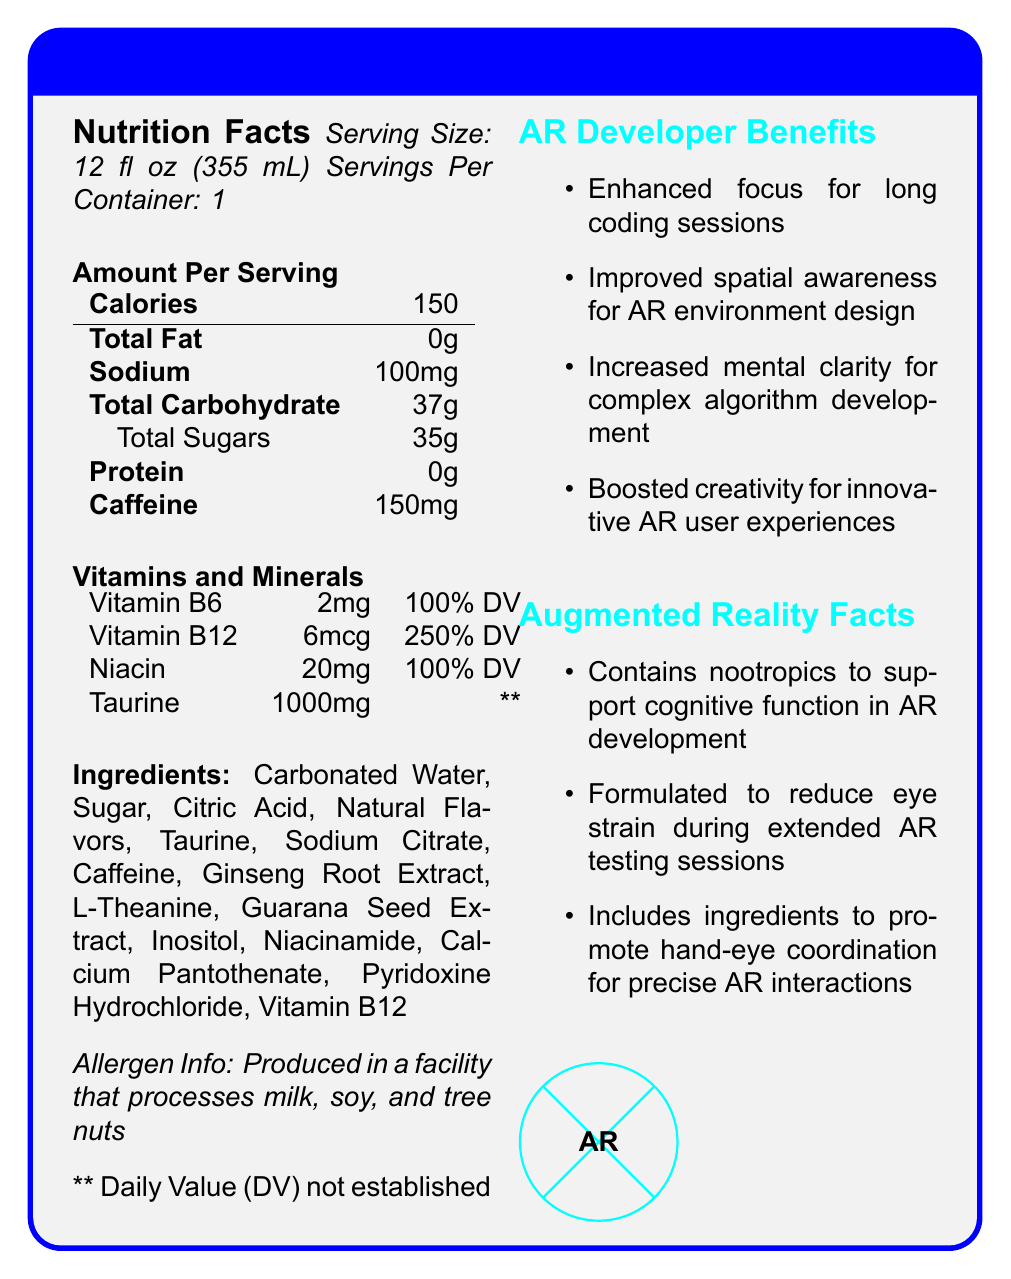What is the serving size of CodeVision AR Boost? The serving size is listed as "12 fl oz (355 mL)" under the Nutrition Facts section.
Answer: 12 fl oz (355 mL) How many calories are in a serving of CodeVision AR Boost? The document specifies that there are "150 calories" per serving in the Nutrition Facts section.
Answer: 150 What is the amount of caffeine in a serving? The amount of caffeine per serving is listed as "150mg" under the Nutrition Facts section.
Answer: 150mg Which vitamins and minerals have established daily values listed? The document lists daily values for Vitamin B6 (100%), Vitamin B12 (250%), and Niacin (100%).
Answer: Vitamin B6, Vitamin B12, Niacin What is listed as the first ingredient? The first ingredient under the Ingredients section is "Carbonated Water".
Answer: Carbonated Water What benefits does CodeVision AR Boost offer for AR developers? The document mentions these benefits under the AR Developer Benefits section.
Answer: Enhanced focus for long coding sessions, Improved spatial awareness for AR environment design, Increased mental clarity for complex algorithm development, Boosted creativity for innovative AR user experiences What are some of the augmented reality-specific features of CodeVision AR Boost? These features are mentioned in the Augmented Reality Facts section.
Answer: Contains nootropics to support cognitive function in AR development, Formulated to reduce eye strain during extended AR testing sessions, Includes ingredients to promote hand-eye coordination for precise AR interactions Which of the following ingredients is NOT listed in CodeVision AR Boost? 
A. Guarana Seed Extract 
B. L-Theanine 
C. Vitamin C Vitamin C is not listed under the Ingredients section.
Answer: C. Vitamin C How many servings per container are there of CodeVision AR Boost?
A. 2
B. 1
C. 3 The document states that there is "1" serving per container.
Answer: B. 1 Does CodeVision AR Boost contain any protein? The Nutrition Facts section lists 0g of protein per serving.
Answer: No Can the daily value of Taurine in CodeVision AR Boost be determined from this document? The daily value for Taurine is labeled "**," and a note states that the daily value has not been established.
Answer: No Is CodeVision AR Boost safe for people with nut allergies? The allergen information states that it is produced in a facility that processes tree nuts, which means there is a potential risk for nut allergies.
Answer: No Summarize the main idea of the document. The document provides detailed information about the nutritional content, ingredients, and AR-specific benefits, emphasizing its design to support cognitive functions and reduce eye strain for developers.
Answer: CodeVision AR Boost is an energy drink tailored for AR developers, providing enhanced focus, improved spatial awareness, increased mental clarity, and boosted creativity through a combination of nootropics, caffeine, and various vitamins and minerals. It has 150 calories per serving and does not contain any fat or protein. 